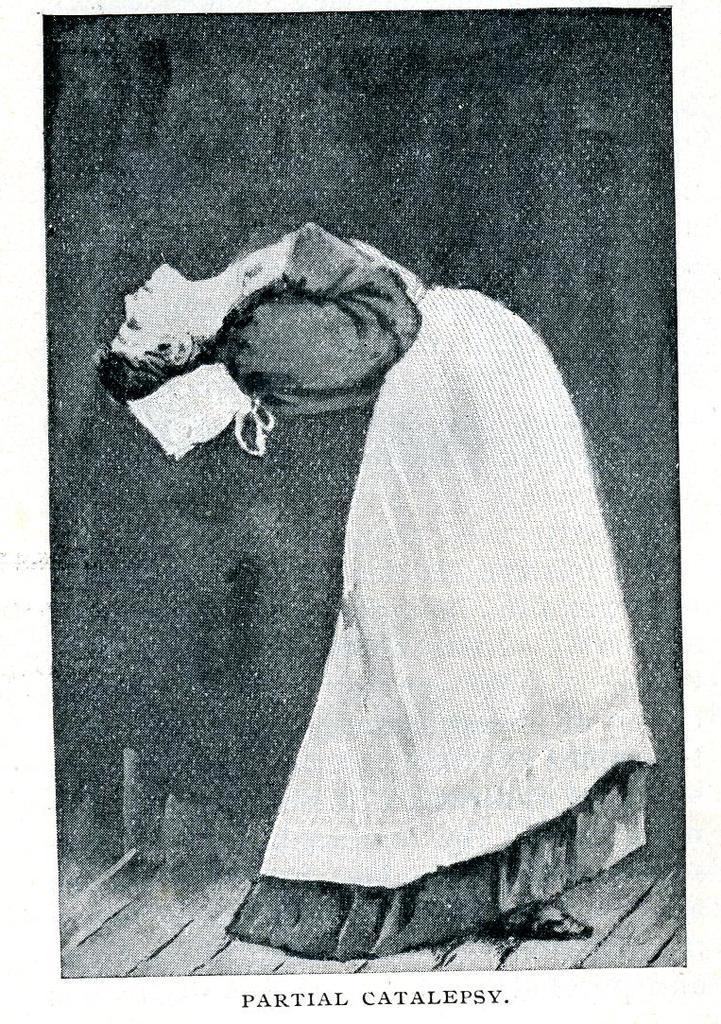What can be inferred about the age of the image? The image appears to be an old picture. Who is present in the image? There is a woman in the image. Where is the woman located in the image? The woman is on a path. What is written on the path in the image? There is text written on the path. What is the woman's annual income in the image? There is no information about the woman's income in the image. How does the woman make her selection in the image? There is no indication of the woman making a selection in the image. 